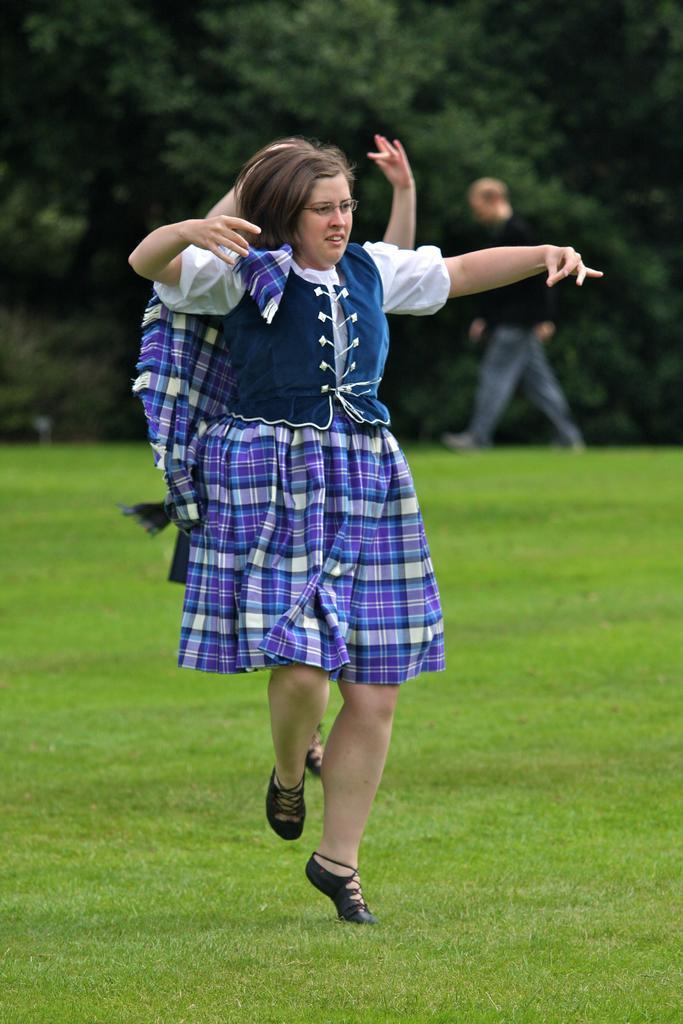Can you describe this image briefly? In this picture we can observe a woman on the ground. She is wearing spectacles. There is some grass on the ground. In the background there is a person walking and there are some trees. 